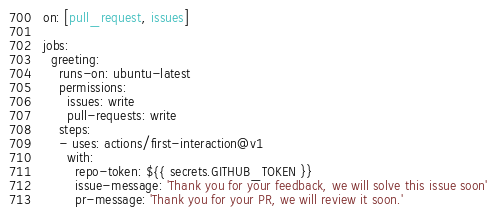Convert code to text. <code><loc_0><loc_0><loc_500><loc_500><_YAML_>on: [pull_request, issues]

jobs:
  greeting:
    runs-on: ubuntu-latest
    permissions:
      issues: write
      pull-requests: write
    steps:
    - uses: actions/first-interaction@v1
      with:
        repo-token: ${{ secrets.GITHUB_TOKEN }}
        issue-message: 'Thank you for your feedback, we will solve this issue soon'
        pr-message: 'Thank you for your PR, we will review it soon.'
</code> 